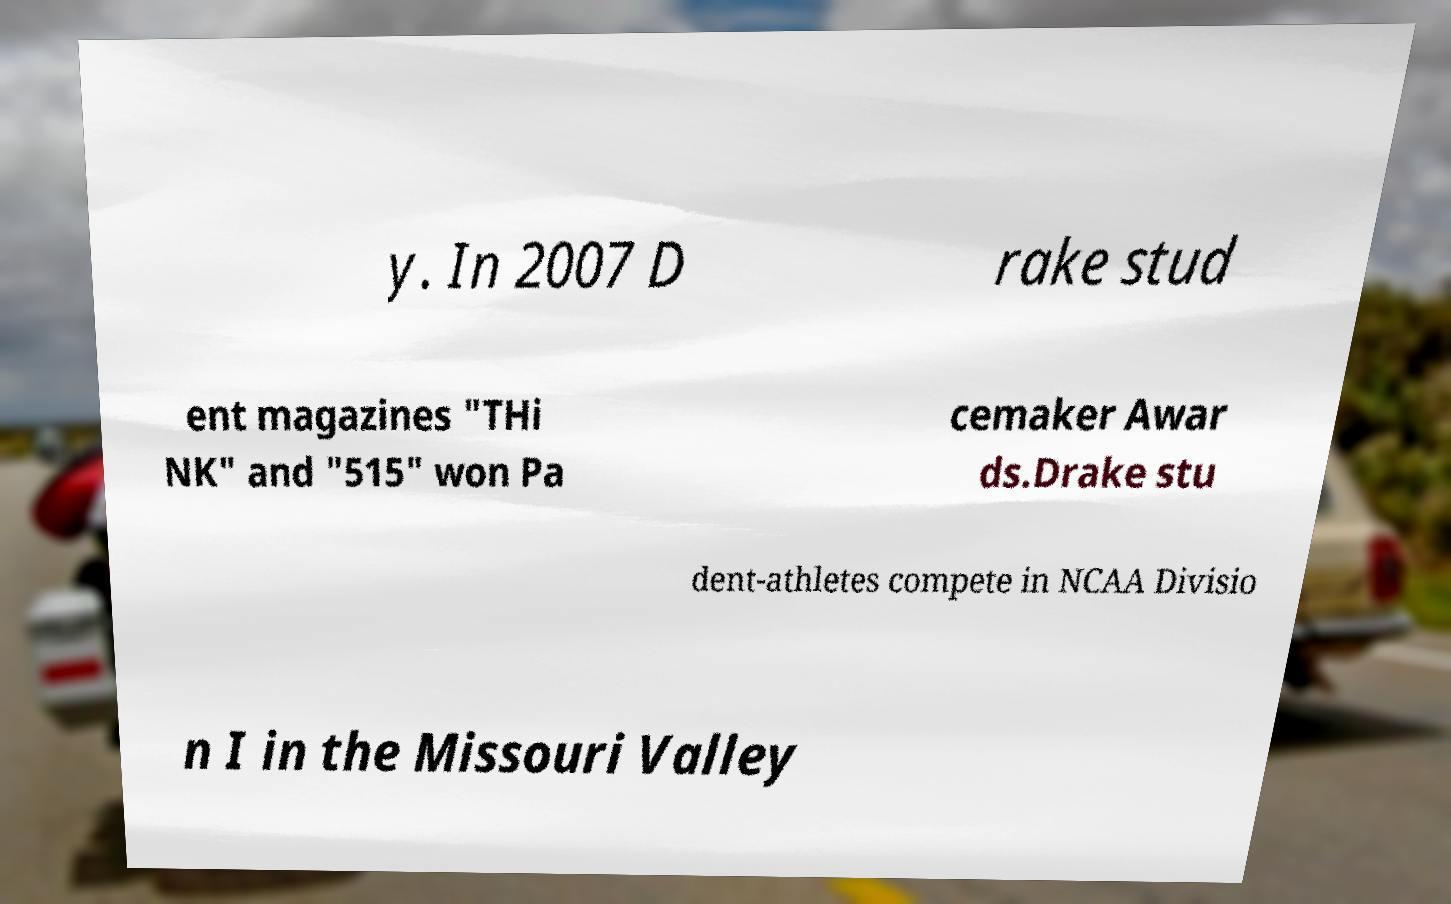Can you accurately transcribe the text from the provided image for me? y. In 2007 D rake stud ent magazines "THi NK" and "515" won Pa cemaker Awar ds.Drake stu dent-athletes compete in NCAA Divisio n I in the Missouri Valley 